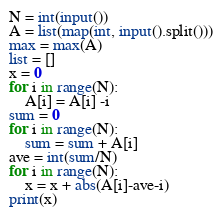Convert code to text. <code><loc_0><loc_0><loc_500><loc_500><_Python_>N = int(input())
A = list(map(int, input().split()))
max = max(A)
list = []
x = 0
for i in range(N):
    A[i] = A[i] -i
sum = 0
for i in range(N):
    sum = sum + A[i]
ave = int(sum/N)
for i in range(N):
    x = x + abs(A[i]-ave-i)
print(x)
</code> 